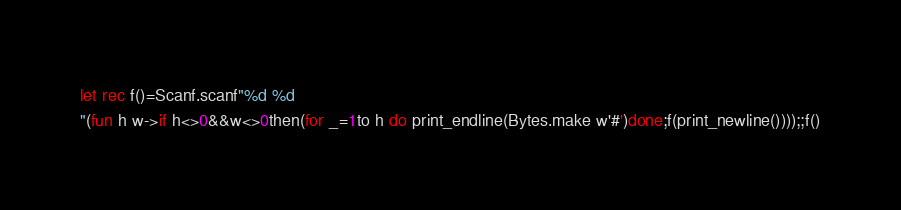<code> <loc_0><loc_0><loc_500><loc_500><_OCaml_>let rec f()=Scanf.scanf"%d %d
"(fun h w->if h<>0&&w<>0then(for _=1to h do print_endline(Bytes.make w'#')done;f(print_newline())));;f()</code> 